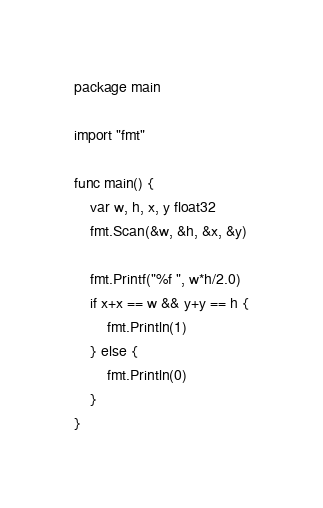Convert code to text. <code><loc_0><loc_0><loc_500><loc_500><_Go_>package main

import "fmt"

func main() {
	var w, h, x, y float32
	fmt.Scan(&w, &h, &x, &y)

	fmt.Printf("%f ", w*h/2.0)
	if x+x == w && y+y == h {
		fmt.Println(1)
	} else {
		fmt.Println(0)
	}
}
</code> 